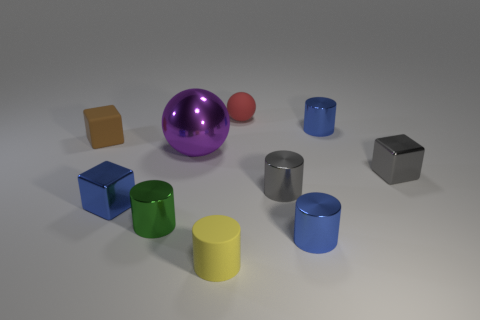Which object stands out the most in this image and why? The purple reflective sphere stands out the most due to its larger size, glossy surface, and vibrant color, all of which draw the viewer's eye amidst the more subdued tones of the surrounding objects. 